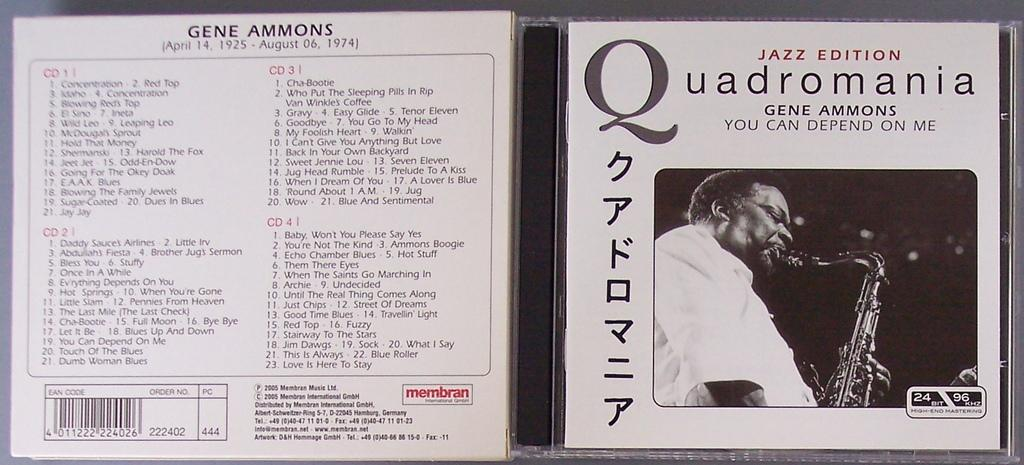What is the color scheme of the image? The image is black and white. What object is featured in the image? There is a disc cover in the image. What information is present on the disc cover? There is text and a bar code on the disc cover. What is depicted on the disc cover? A person playing a musical instrument is depicted on the disc cover. What type of leather is used to make the vacation bag in the image? There is no vacation bag or leather present in the image; it features a disc cover with a person playing a musical instrument. 